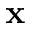Convert formula to latex. <formula><loc_0><loc_0><loc_500><loc_500>x</formula> 